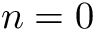<formula> <loc_0><loc_0><loc_500><loc_500>n = 0</formula> 